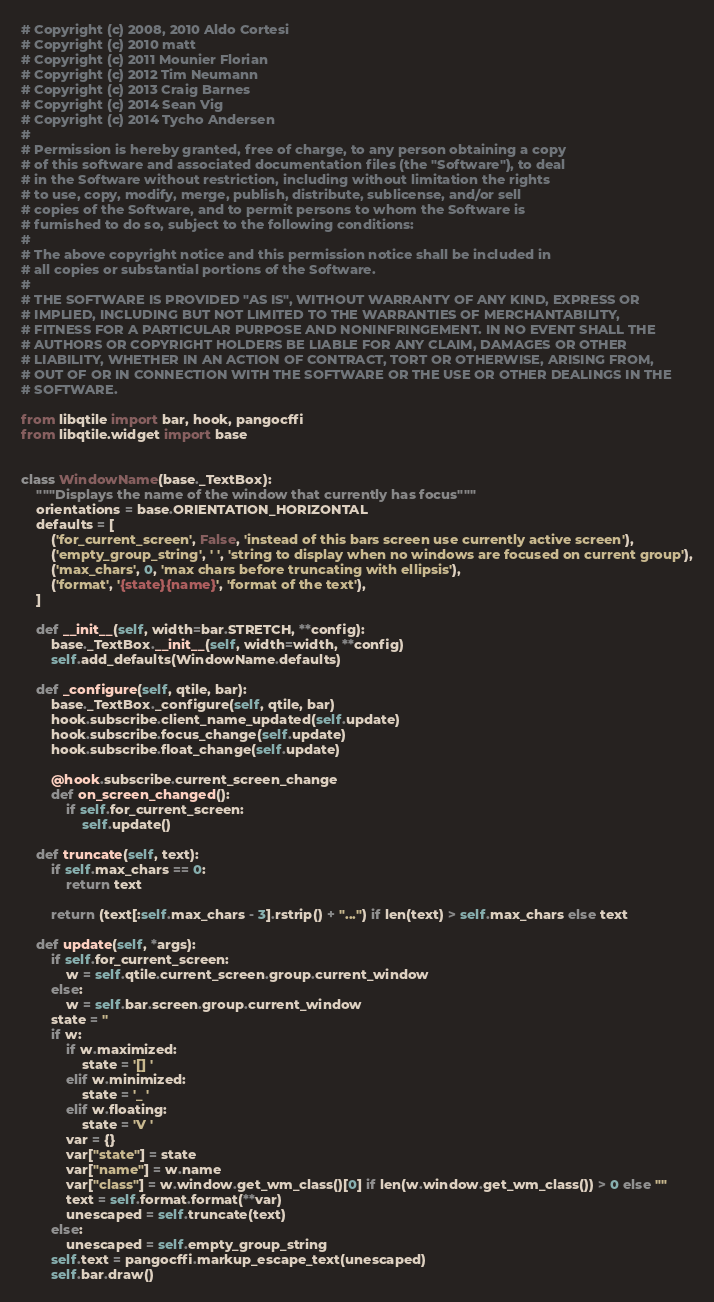<code> <loc_0><loc_0><loc_500><loc_500><_Python_># Copyright (c) 2008, 2010 Aldo Cortesi
# Copyright (c) 2010 matt
# Copyright (c) 2011 Mounier Florian
# Copyright (c) 2012 Tim Neumann
# Copyright (c) 2013 Craig Barnes
# Copyright (c) 2014 Sean Vig
# Copyright (c) 2014 Tycho Andersen
#
# Permission is hereby granted, free of charge, to any person obtaining a copy
# of this software and associated documentation files (the "Software"), to deal
# in the Software without restriction, including without limitation the rights
# to use, copy, modify, merge, publish, distribute, sublicense, and/or sell
# copies of the Software, and to permit persons to whom the Software is
# furnished to do so, subject to the following conditions:
#
# The above copyright notice and this permission notice shall be included in
# all copies or substantial portions of the Software.
#
# THE SOFTWARE IS PROVIDED "AS IS", WITHOUT WARRANTY OF ANY KIND, EXPRESS OR
# IMPLIED, INCLUDING BUT NOT LIMITED TO THE WARRANTIES OF MERCHANTABILITY,
# FITNESS FOR A PARTICULAR PURPOSE AND NONINFRINGEMENT. IN NO EVENT SHALL THE
# AUTHORS OR COPYRIGHT HOLDERS BE LIABLE FOR ANY CLAIM, DAMAGES OR OTHER
# LIABILITY, WHETHER IN AN ACTION OF CONTRACT, TORT OR OTHERWISE, ARISING FROM,
# OUT OF OR IN CONNECTION WITH THE SOFTWARE OR THE USE OR OTHER DEALINGS IN THE
# SOFTWARE.

from libqtile import bar, hook, pangocffi
from libqtile.widget import base


class WindowName(base._TextBox):
    """Displays the name of the window that currently has focus"""
    orientations = base.ORIENTATION_HORIZONTAL
    defaults = [
        ('for_current_screen', False, 'instead of this bars screen use currently active screen'),
        ('empty_group_string', ' ', 'string to display when no windows are focused on current group'),
        ('max_chars', 0, 'max chars before truncating with ellipsis'),
        ('format', '{state}{name}', 'format of the text'),
    ]

    def __init__(self, width=bar.STRETCH, **config):
        base._TextBox.__init__(self, width=width, **config)
        self.add_defaults(WindowName.defaults)

    def _configure(self, qtile, bar):
        base._TextBox._configure(self, qtile, bar)
        hook.subscribe.client_name_updated(self.update)
        hook.subscribe.focus_change(self.update)
        hook.subscribe.float_change(self.update)

        @hook.subscribe.current_screen_change
        def on_screen_changed():
            if self.for_current_screen:
                self.update()

    def truncate(self, text):
        if self.max_chars == 0:
            return text

        return (text[:self.max_chars - 3].rstrip() + "...") if len(text) > self.max_chars else text

    def update(self, *args):
        if self.for_current_screen:
            w = self.qtile.current_screen.group.current_window
        else:
            w = self.bar.screen.group.current_window
        state = ''
        if w:
            if w.maximized:
                state = '[] '
            elif w.minimized:
                state = '_ '
            elif w.floating:
                state = 'V '
            var = {}
            var["state"] = state
            var["name"] = w.name
            var["class"] = w.window.get_wm_class()[0] if len(w.window.get_wm_class()) > 0 else ""
            text = self.format.format(**var)
            unescaped = self.truncate(text)
        else:
            unescaped = self.empty_group_string
        self.text = pangocffi.markup_escape_text(unescaped)
        self.bar.draw()
</code> 